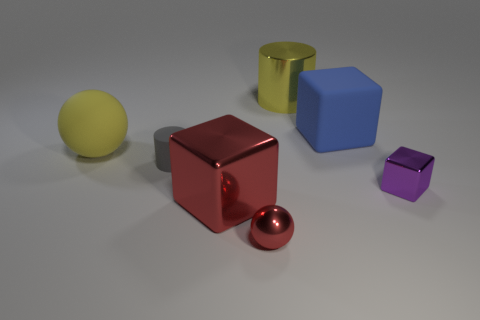Add 2 yellow metallic things. How many objects exist? 9 Subtract all blocks. How many objects are left? 4 Subtract 1 yellow balls. How many objects are left? 6 Subtract all large spheres. Subtract all gray cylinders. How many objects are left? 5 Add 6 big things. How many big things are left? 10 Add 2 gray metal things. How many gray metal things exist? 2 